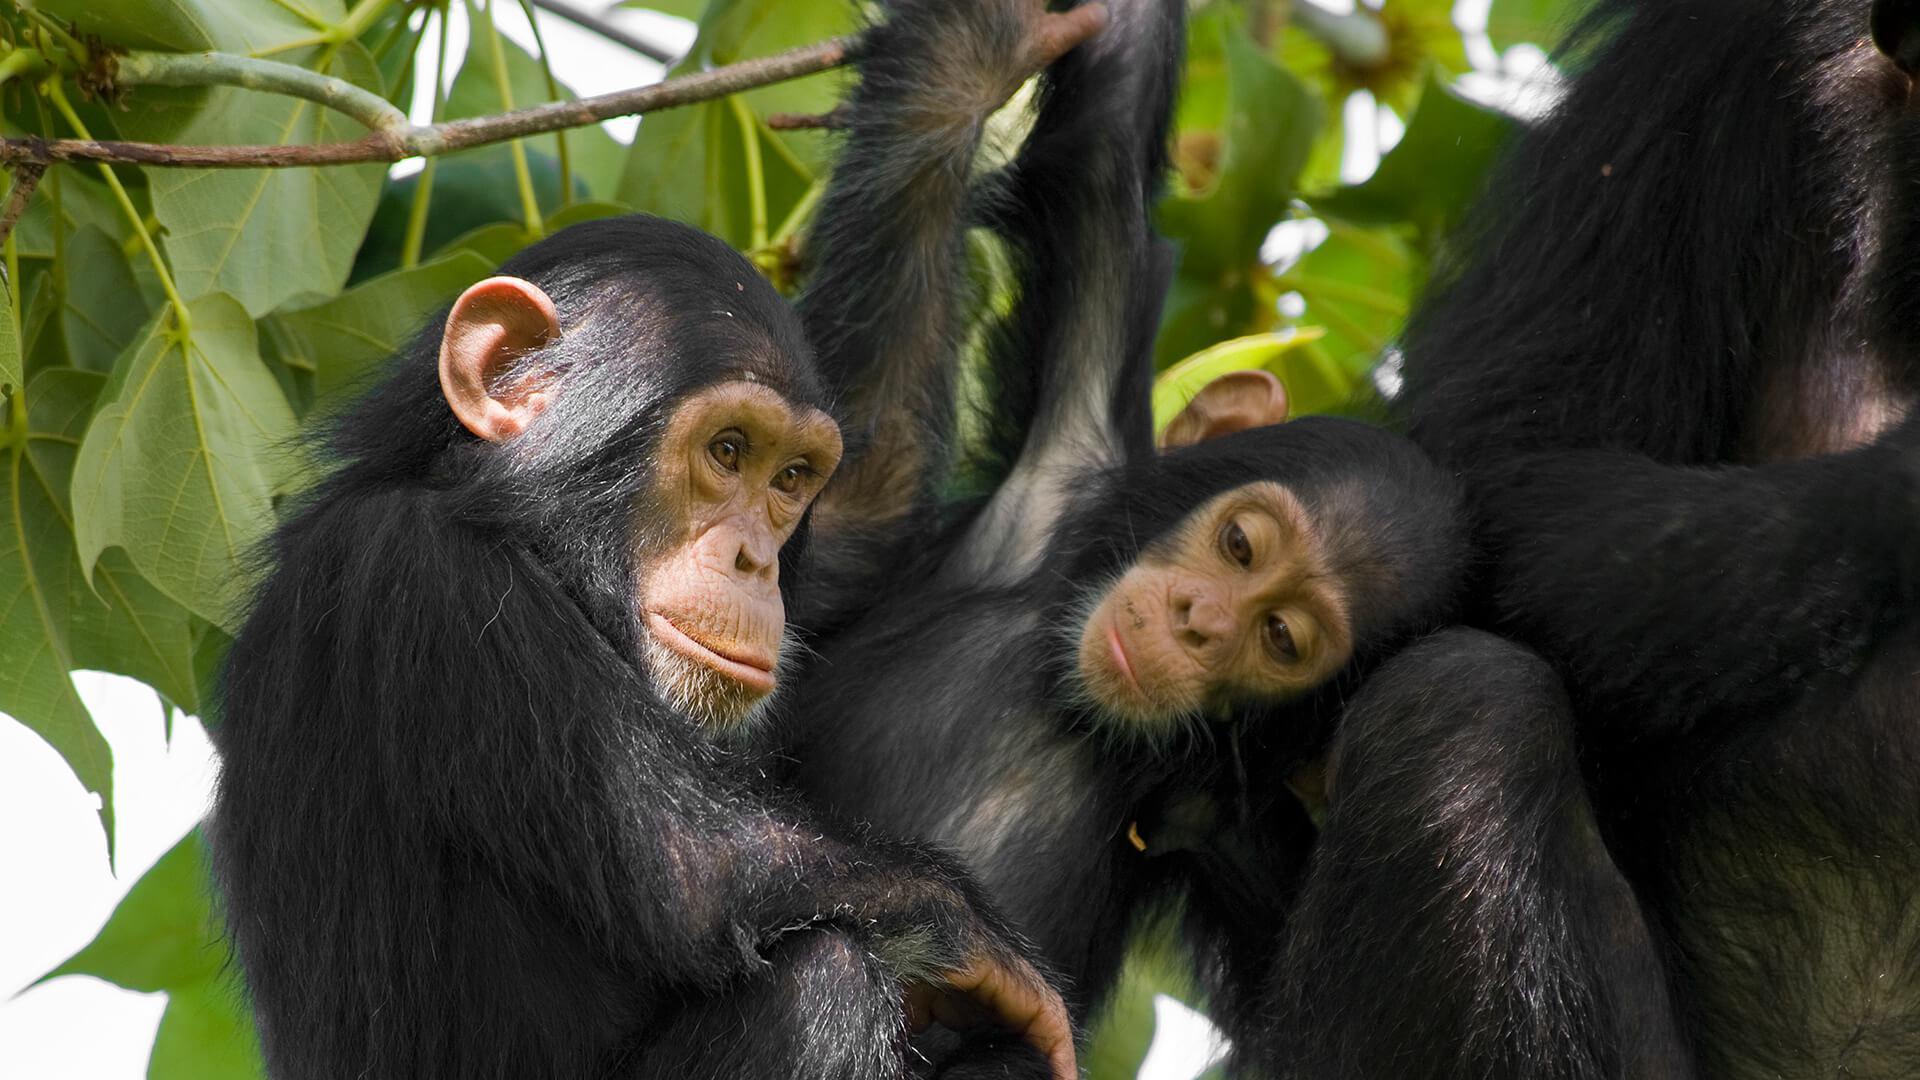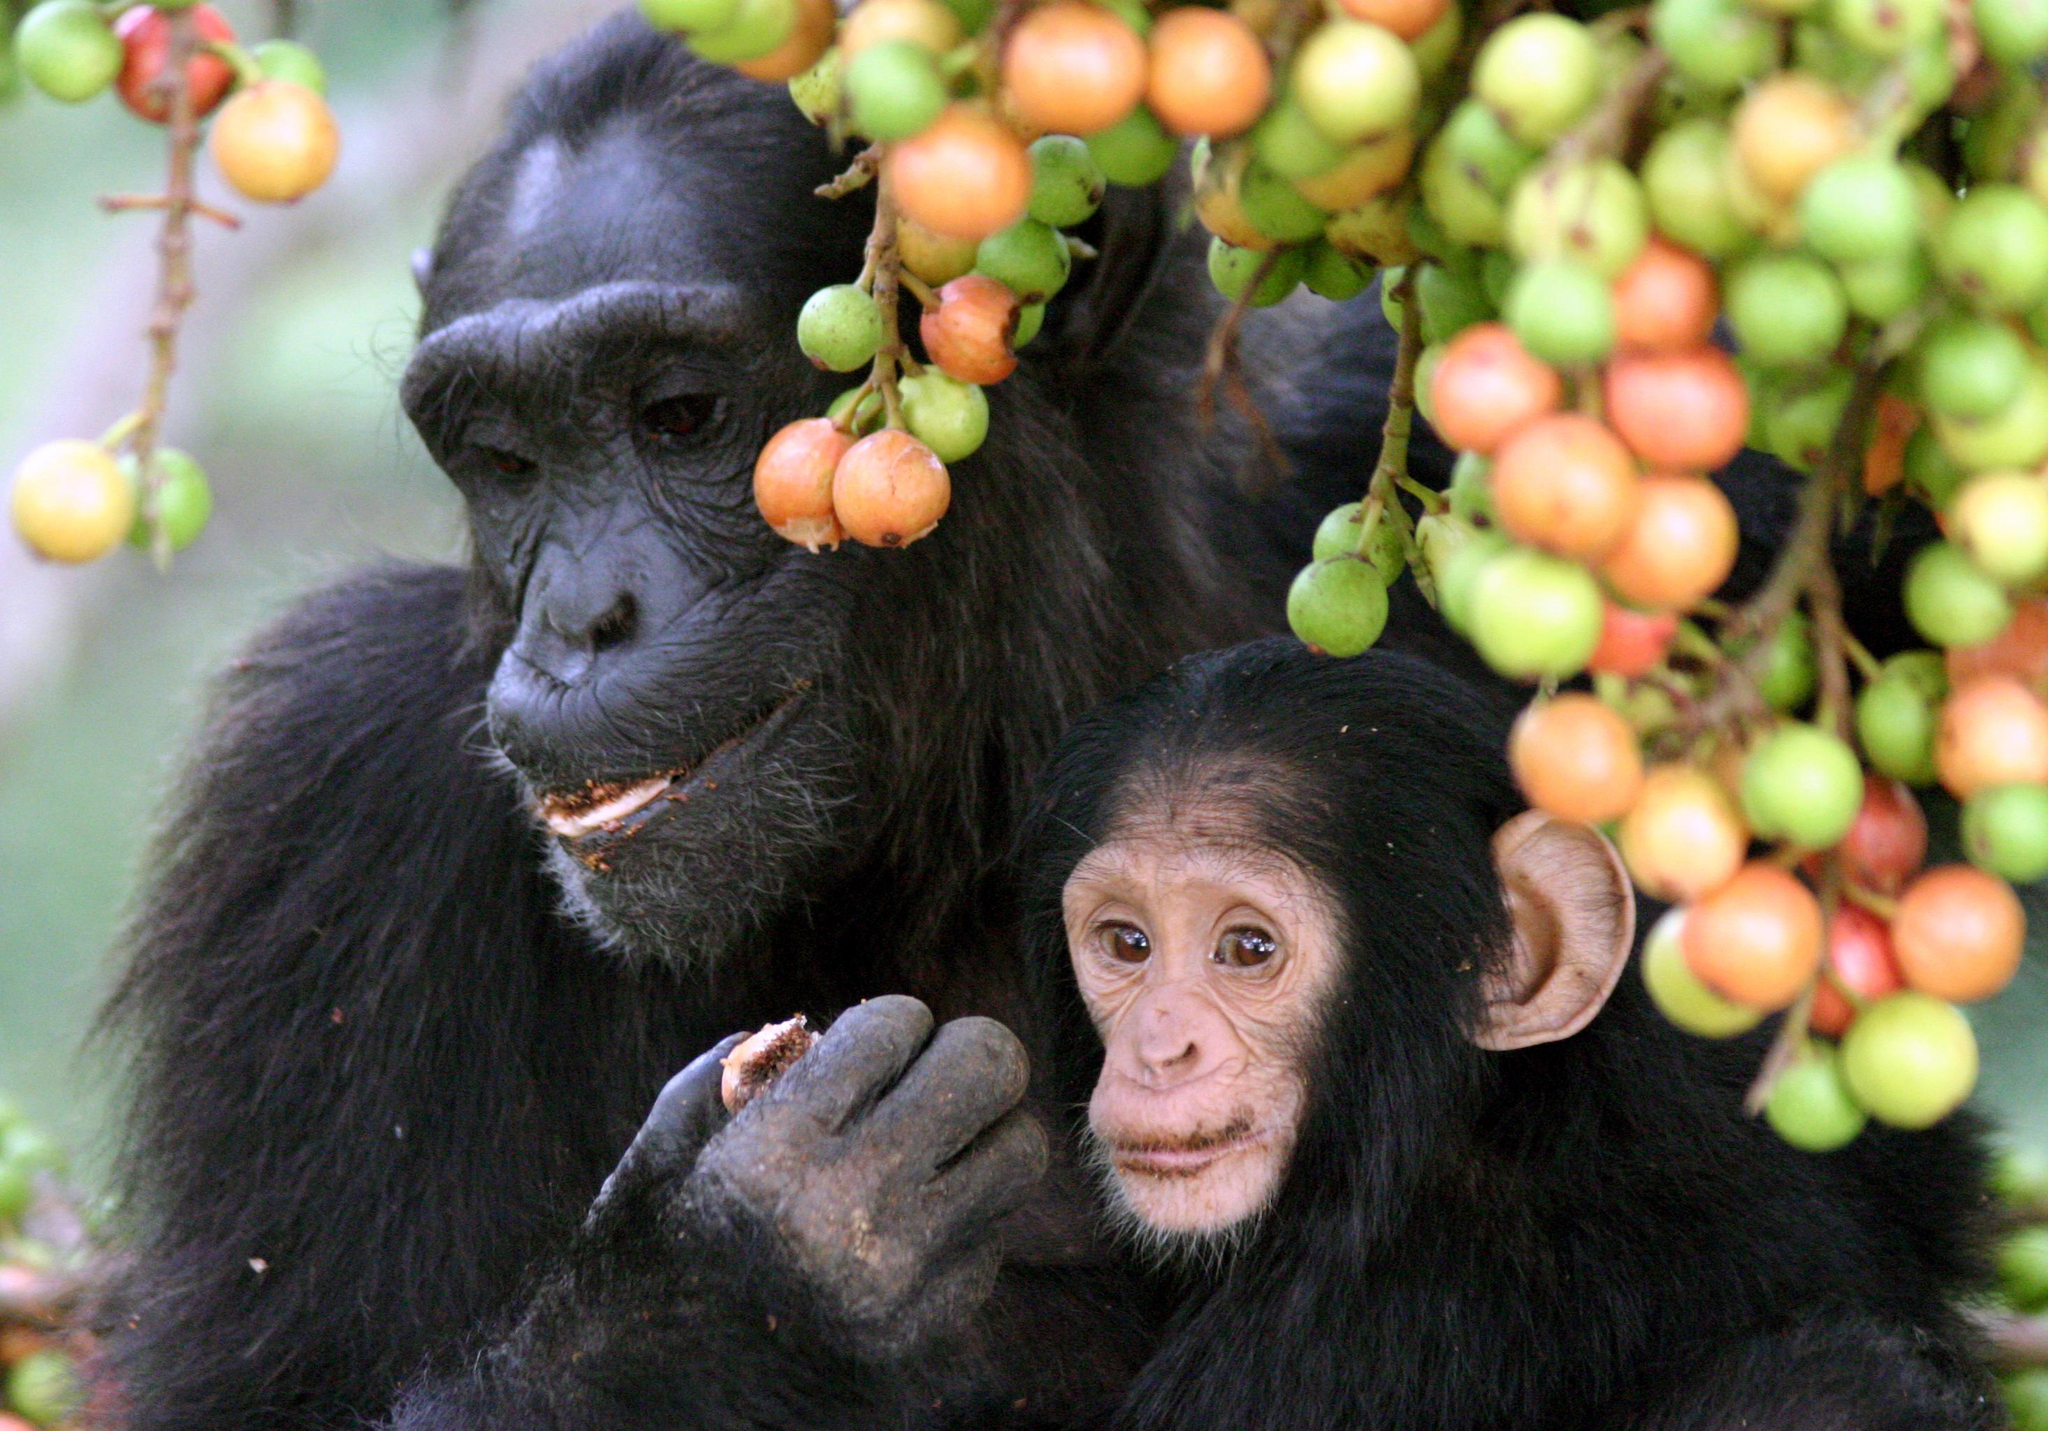The first image is the image on the left, the second image is the image on the right. Assess this claim about the two images: "There is green food in the mouth of the monkey in the image on the right.". Correct or not? Answer yes or no. No. 